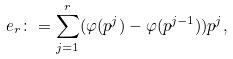Convert formula to latex. <formula><loc_0><loc_0><loc_500><loc_500>e _ { r } \colon = \sum _ { j = 1 } ^ { r } ( \varphi ( p ^ { j } ) - \varphi ( p ^ { j - 1 } ) ) p ^ { j } ,</formula> 